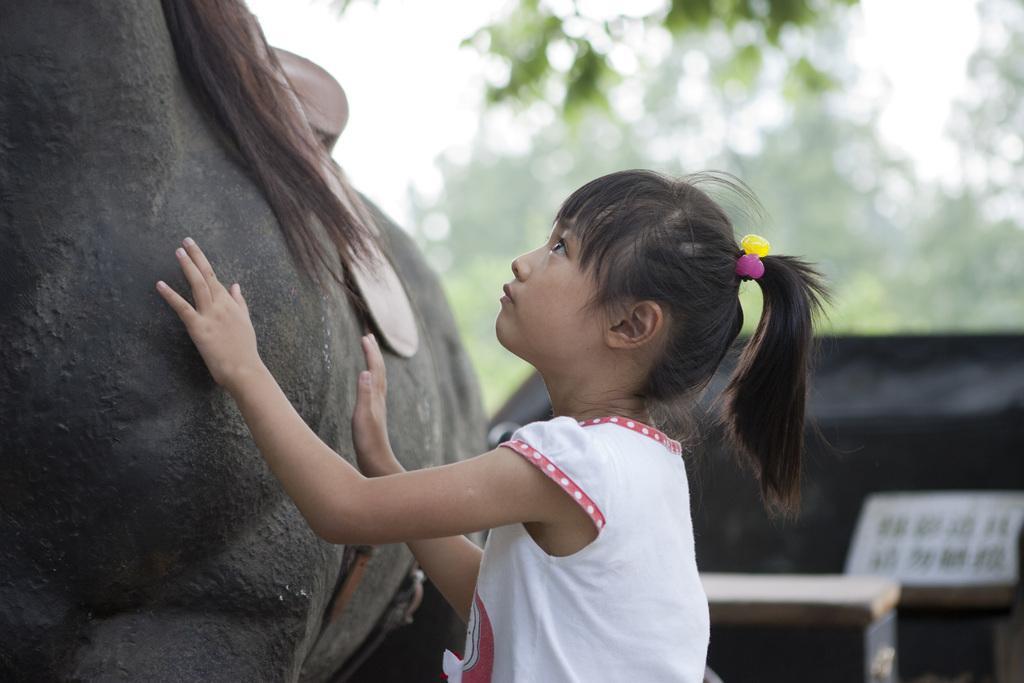Please provide a concise description of this image. In this picture there is a girl, in front of her we can see an animal. In the background of the image it is blurry and we can see objects. 